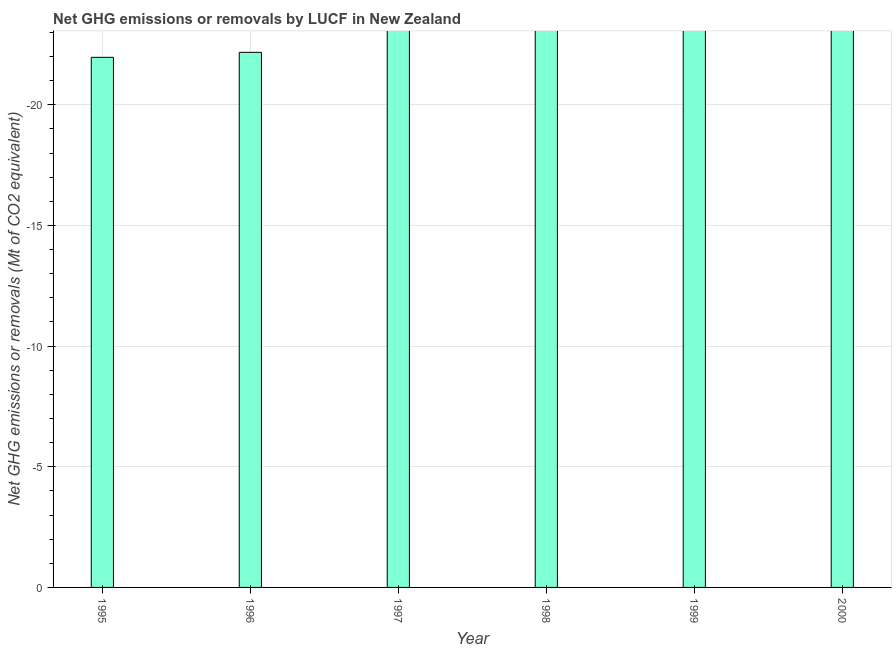Does the graph contain any zero values?
Keep it short and to the point. Yes. Does the graph contain grids?
Offer a terse response. Yes. What is the title of the graph?
Ensure brevity in your answer.  Net GHG emissions or removals by LUCF in New Zealand. What is the label or title of the X-axis?
Your answer should be compact. Year. What is the label or title of the Y-axis?
Your answer should be compact. Net GHG emissions or removals (Mt of CO2 equivalent). Across all years, what is the minimum ghg net emissions or removals?
Offer a terse response. 0. What is the sum of the ghg net emissions or removals?
Your answer should be compact. 0. What is the average ghg net emissions or removals per year?
Your answer should be compact. 0. How many bars are there?
Offer a terse response. 0. Are all the bars in the graph horizontal?
Keep it short and to the point. No. What is the difference between two consecutive major ticks on the Y-axis?
Keep it short and to the point. 5. What is the Net GHG emissions or removals (Mt of CO2 equivalent) in 1996?
Your answer should be very brief. 0. What is the Net GHG emissions or removals (Mt of CO2 equivalent) in 1997?
Provide a succinct answer. 0. What is the Net GHG emissions or removals (Mt of CO2 equivalent) in 1998?
Provide a short and direct response. 0. What is the Net GHG emissions or removals (Mt of CO2 equivalent) of 1999?
Offer a very short reply. 0. What is the Net GHG emissions or removals (Mt of CO2 equivalent) in 2000?
Offer a terse response. 0. 